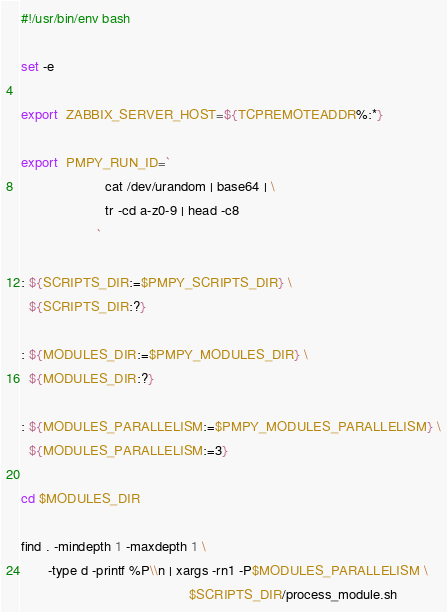Convert code to text. <code><loc_0><loc_0><loc_500><loc_500><_Bash_>#!/usr/bin/env bash

set -e

export  ZABBIX_SERVER_HOST=${TCPREMOTEADDR%:*}

export  PMPY_RUN_ID=`
                      cat /dev/urandom | base64 | \
                      tr -cd a-z0-9 | head -c8
                    `

: ${SCRIPTS_DIR:=$PMPY_SCRIPTS_DIR} \
  ${SCRIPTS_DIR:?}

: ${MODULES_DIR:=$PMPY_MODULES_DIR} \
  ${MODULES_DIR:?}

: ${MODULES_PARALLELISM:=$PMPY_MODULES_PARALLELISM} \
  ${MODULES_PARALLELISM:=3}

cd $MODULES_DIR

find . -mindepth 1 -maxdepth 1 \
       -type d -printf %P\\n | xargs -rn1 -P$MODULES_PARALLELISM \
                                            $SCRIPTS_DIR/process_module.sh
</code> 